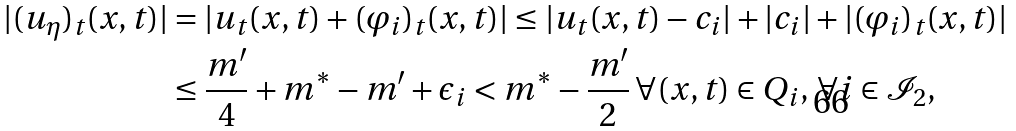Convert formula to latex. <formula><loc_0><loc_0><loc_500><loc_500>| ( u _ { \eta } ) _ { t } ( x , t ) | & = | u _ { t } ( x , t ) + ( \varphi _ { i } ) _ { t } ( x , t ) | \leq | u _ { t } ( x , t ) - c _ { i } | + | c _ { i } | + | ( \varphi _ { i } ) _ { t } ( x , t ) | \\ & \leq \frac { m ^ { \prime } } { 4 } + m ^ { * } - m ^ { \prime } + \epsilon _ { i } < m ^ { * } - \frac { m ^ { \prime } } { 2 } \, \forall ( x , t ) \in Q _ { i } , \, \forall i \in \mathcal { I } _ { 2 } ,</formula> 